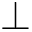Convert formula to latex. <formula><loc_0><loc_0><loc_500><loc_500>\perp</formula> 